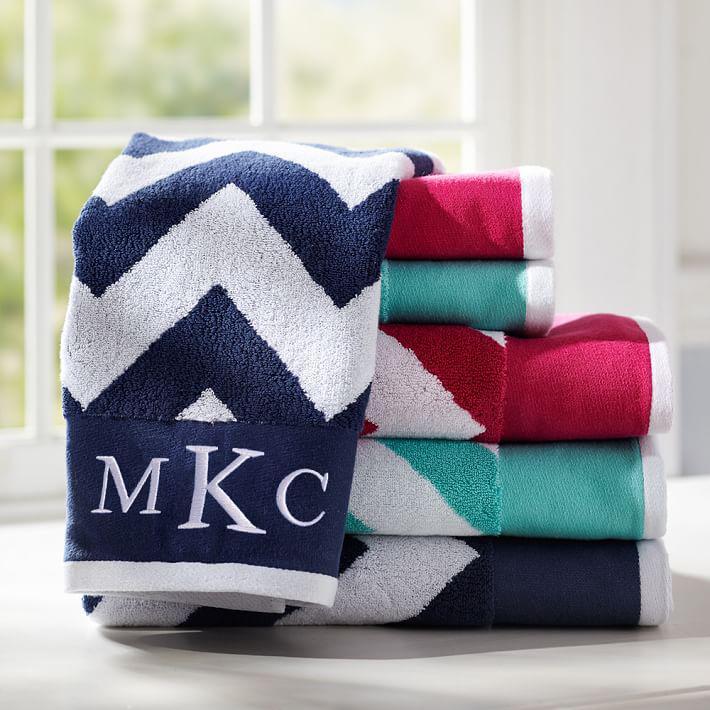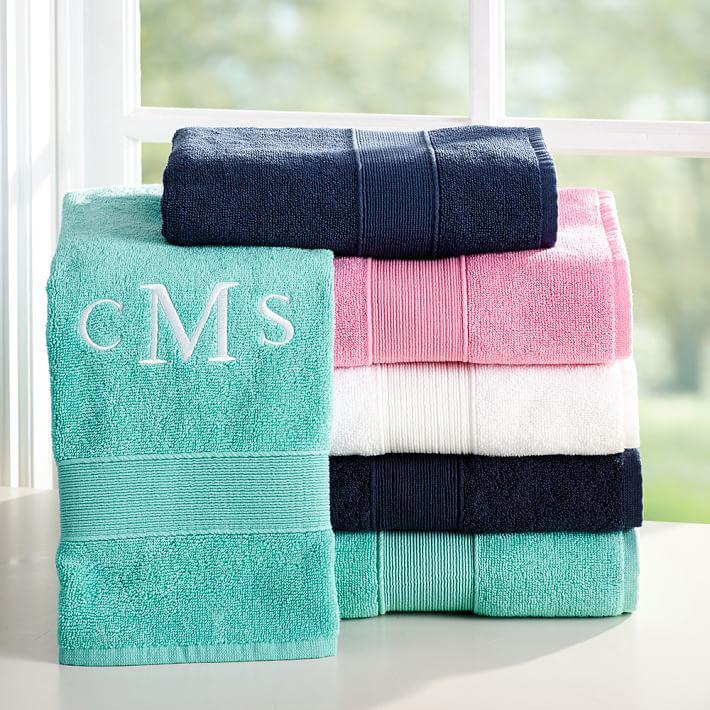The first image is the image on the left, the second image is the image on the right. Evaluate the accuracy of this statement regarding the images: "There is at least one towel that is primarily a pinkish hue in color". Is it true? Answer yes or no. Yes. The first image is the image on the left, the second image is the image on the right. Assess this claim about the two images: "The middle letter in the monogram on several of the towels is a capital R.". Correct or not? Answer yes or no. No. 